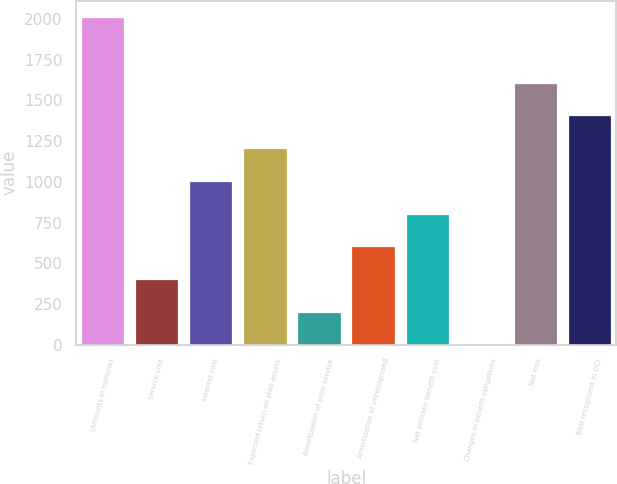Convert chart to OTSL. <chart><loc_0><loc_0><loc_500><loc_500><bar_chart><fcel>(Amounts in millions)<fcel>Service cost<fcel>Interest cost<fcel>Expected return on plan assets<fcel>Amortization of prior service<fcel>Amortization of unrecognized<fcel>Net periodic benefit cost<fcel>Changes in benefit obligations<fcel>Net loss<fcel>Total recognized in OCI<nl><fcel>2011<fcel>402.36<fcel>1005.6<fcel>1206.68<fcel>201.28<fcel>603.44<fcel>804.52<fcel>0.2<fcel>1608.84<fcel>1407.76<nl></chart> 